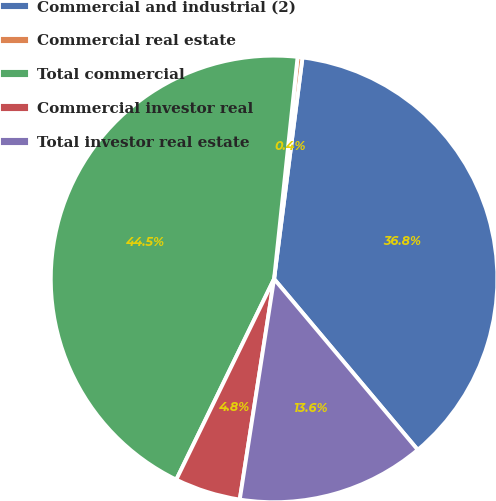Convert chart to OTSL. <chart><loc_0><loc_0><loc_500><loc_500><pie_chart><fcel>Commercial and industrial (2)<fcel>Commercial real estate<fcel>Total commercial<fcel>Commercial investor real<fcel>Total investor real estate<nl><fcel>36.84%<fcel>0.35%<fcel>44.46%<fcel>4.76%<fcel>13.58%<nl></chart> 